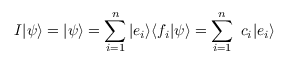<formula> <loc_0><loc_0><loc_500><loc_500>I | \psi \rangle = | \psi \rangle = \sum _ { i = 1 } ^ { n } | e _ { i } \rangle \langle f _ { i } | \psi \rangle = \sum _ { i = 1 } ^ { n } \ c _ { i } | e _ { i } \rangle</formula> 